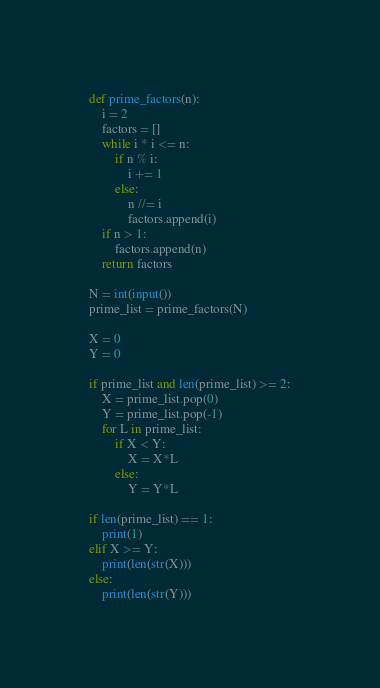<code> <loc_0><loc_0><loc_500><loc_500><_Python_>def prime_factors(n):
    i = 2
    factors = []
    while i * i <= n:
        if n % i:
            i += 1
        else:
            n //= i
            factors.append(i)
    if n > 1:
        factors.append(n)
    return factors

N = int(input())
prime_list = prime_factors(N)

X = 0
Y = 0

if prime_list and len(prime_list) >= 2:
    X = prime_list.pop(0)
    Y = prime_list.pop(-1)
    for L in prime_list:
        if X < Y:
            X = X*L
        else:
            Y = Y*L

if len(prime_list) == 1:
    print(1)
elif X >= Y:
    print(len(str(X)))
else:
    print(len(str(Y)))</code> 